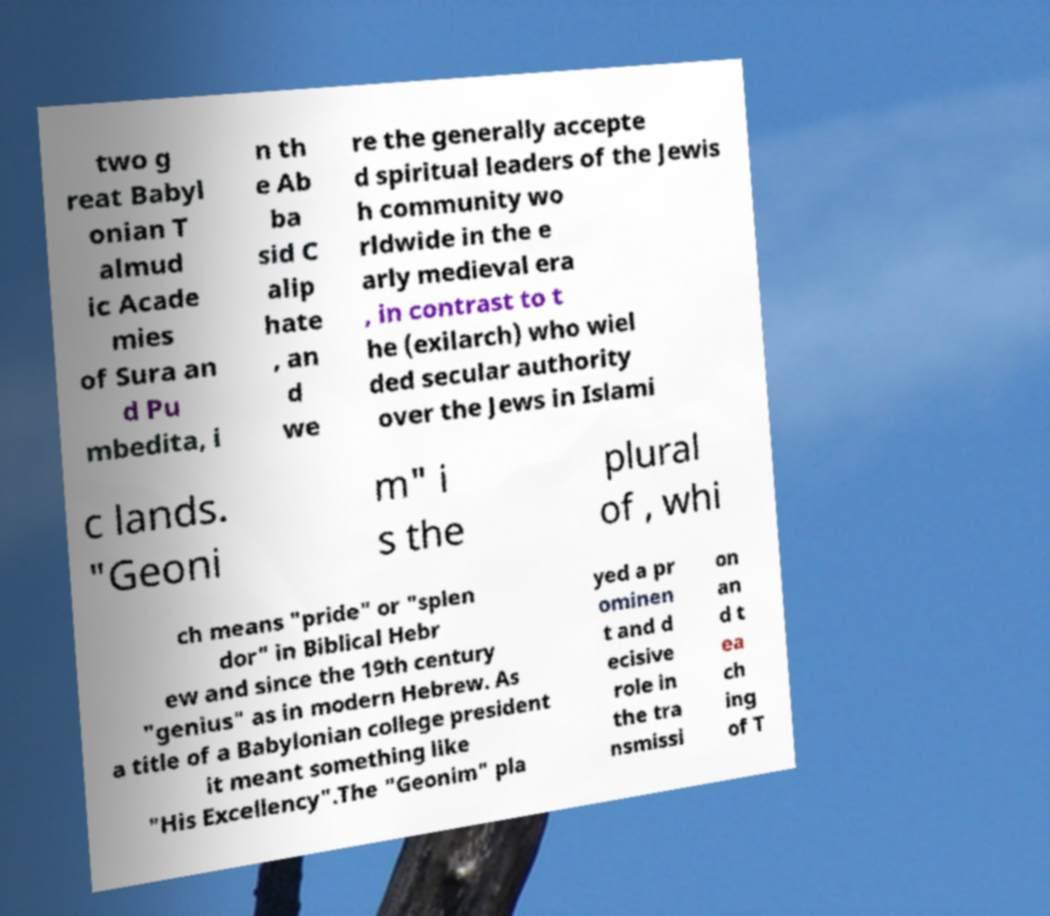Could you assist in decoding the text presented in this image and type it out clearly? two g reat Babyl onian T almud ic Acade mies of Sura an d Pu mbedita, i n th e Ab ba sid C alip hate , an d we re the generally accepte d spiritual leaders of the Jewis h community wo rldwide in the e arly medieval era , in contrast to t he (exilarch) who wiel ded secular authority over the Jews in Islami c lands. "Geoni m" i s the plural of , whi ch means "pride" or "splen dor" in Biblical Hebr ew and since the 19th century "genius" as in modern Hebrew. As a title of a Babylonian college president it meant something like "His Excellency".The "Geonim" pla yed a pr ominen t and d ecisive role in the tra nsmissi on an d t ea ch ing of T 